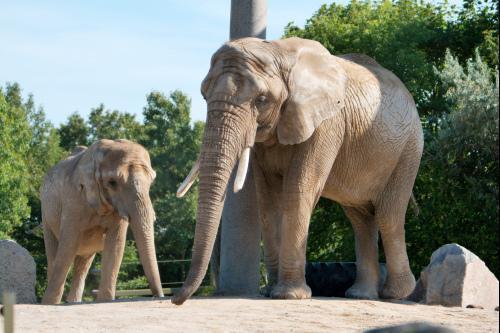How many elephants are in the picture?
Give a very brief answer. 2. How many zebras are eating off the ground?
Give a very brief answer. 0. 